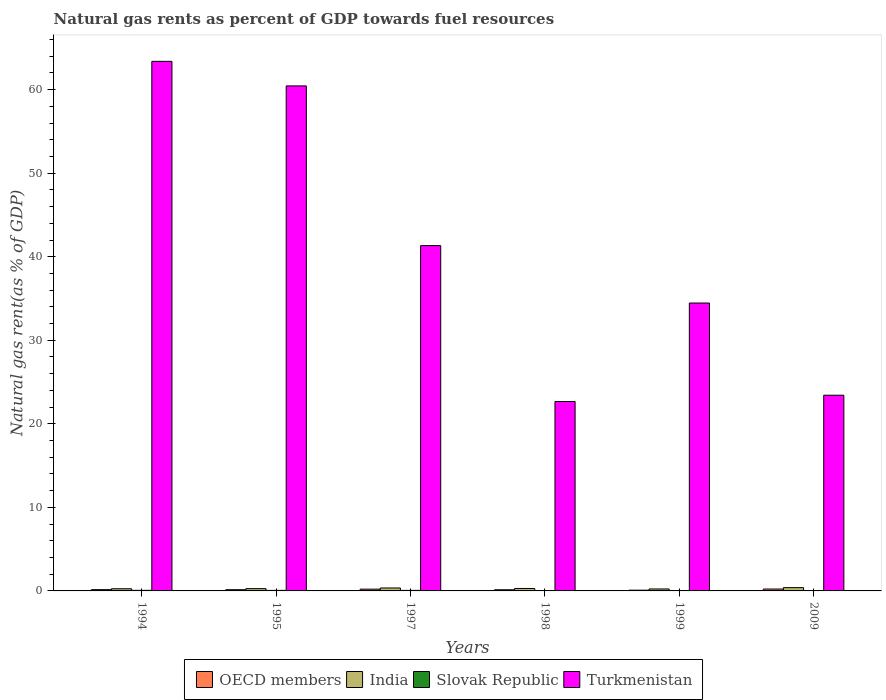How many groups of bars are there?
Provide a succinct answer. 6. Are the number of bars per tick equal to the number of legend labels?
Provide a succinct answer. Yes. How many bars are there on the 1st tick from the right?
Give a very brief answer. 4. What is the label of the 5th group of bars from the left?
Provide a succinct answer. 1999. In how many cases, is the number of bars for a given year not equal to the number of legend labels?
Your answer should be very brief. 0. What is the natural gas rent in India in 1994?
Your answer should be compact. 0.26. Across all years, what is the maximum natural gas rent in OECD members?
Your answer should be compact. 0.23. Across all years, what is the minimum natural gas rent in OECD members?
Make the answer very short. 0.09. What is the total natural gas rent in Turkmenistan in the graph?
Provide a short and direct response. 245.71. What is the difference between the natural gas rent in India in 1997 and that in 2009?
Your answer should be very brief. -0.04. What is the difference between the natural gas rent in India in 1997 and the natural gas rent in Slovak Republic in 1994?
Your response must be concise. 0.28. What is the average natural gas rent in Slovak Republic per year?
Offer a terse response. 0.05. In the year 2009, what is the difference between the natural gas rent in Turkmenistan and natural gas rent in OECD members?
Offer a very short reply. 23.2. What is the ratio of the natural gas rent in OECD members in 1997 to that in 1998?
Provide a succinct answer. 1.51. Is the natural gas rent in OECD members in 1997 less than that in 1998?
Provide a short and direct response. No. What is the difference between the highest and the second highest natural gas rent in India?
Make the answer very short. 0.04. What is the difference between the highest and the lowest natural gas rent in India?
Your answer should be very brief. 0.16. What does the 4th bar from the left in 1995 represents?
Provide a succinct answer. Turkmenistan. What does the 1st bar from the right in 2009 represents?
Provide a short and direct response. Turkmenistan. What is the difference between two consecutive major ticks on the Y-axis?
Give a very brief answer. 10. Does the graph contain any zero values?
Make the answer very short. No. Does the graph contain grids?
Ensure brevity in your answer.  No. Where does the legend appear in the graph?
Provide a succinct answer. Bottom center. How many legend labels are there?
Keep it short and to the point. 4. How are the legend labels stacked?
Make the answer very short. Horizontal. What is the title of the graph?
Your answer should be very brief. Natural gas rents as percent of GDP towards fuel resources. Does "Azerbaijan" appear as one of the legend labels in the graph?
Your response must be concise. No. What is the label or title of the Y-axis?
Your answer should be very brief. Natural gas rent(as % of GDP). What is the Natural gas rent(as % of GDP) of OECD members in 1994?
Your answer should be compact. 0.15. What is the Natural gas rent(as % of GDP) in India in 1994?
Your answer should be very brief. 0.26. What is the Natural gas rent(as % of GDP) in Slovak Republic in 1994?
Offer a very short reply. 0.07. What is the Natural gas rent(as % of GDP) in Turkmenistan in 1994?
Keep it short and to the point. 63.38. What is the Natural gas rent(as % of GDP) in OECD members in 1995?
Provide a succinct answer. 0.15. What is the Natural gas rent(as % of GDP) in India in 1995?
Make the answer very short. 0.27. What is the Natural gas rent(as % of GDP) in Slovak Republic in 1995?
Your answer should be very brief. 0.07. What is the Natural gas rent(as % of GDP) of Turkmenistan in 1995?
Make the answer very short. 60.45. What is the Natural gas rent(as % of GDP) in OECD members in 1997?
Ensure brevity in your answer.  0.21. What is the Natural gas rent(as % of GDP) in India in 1997?
Your response must be concise. 0.35. What is the Natural gas rent(as % of GDP) in Slovak Republic in 1997?
Your answer should be very brief. 0.06. What is the Natural gas rent(as % of GDP) of Turkmenistan in 1997?
Ensure brevity in your answer.  41.33. What is the Natural gas rent(as % of GDP) of OECD members in 1998?
Your answer should be compact. 0.14. What is the Natural gas rent(as % of GDP) in India in 1998?
Give a very brief answer. 0.29. What is the Natural gas rent(as % of GDP) in Slovak Republic in 1998?
Provide a succinct answer. 0.04. What is the Natural gas rent(as % of GDP) in Turkmenistan in 1998?
Provide a succinct answer. 22.67. What is the Natural gas rent(as % of GDP) of OECD members in 1999?
Keep it short and to the point. 0.09. What is the Natural gas rent(as % of GDP) in India in 1999?
Your answer should be compact. 0.23. What is the Natural gas rent(as % of GDP) in Slovak Republic in 1999?
Keep it short and to the point. 0.03. What is the Natural gas rent(as % of GDP) of Turkmenistan in 1999?
Ensure brevity in your answer.  34.46. What is the Natural gas rent(as % of GDP) in OECD members in 2009?
Your response must be concise. 0.23. What is the Natural gas rent(as % of GDP) of India in 2009?
Give a very brief answer. 0.39. What is the Natural gas rent(as % of GDP) in Slovak Republic in 2009?
Your answer should be compact. 0.02. What is the Natural gas rent(as % of GDP) of Turkmenistan in 2009?
Offer a very short reply. 23.42. Across all years, what is the maximum Natural gas rent(as % of GDP) of OECD members?
Offer a very short reply. 0.23. Across all years, what is the maximum Natural gas rent(as % of GDP) in India?
Your answer should be very brief. 0.39. Across all years, what is the maximum Natural gas rent(as % of GDP) of Slovak Republic?
Your answer should be very brief. 0.07. Across all years, what is the maximum Natural gas rent(as % of GDP) in Turkmenistan?
Offer a very short reply. 63.38. Across all years, what is the minimum Natural gas rent(as % of GDP) in OECD members?
Provide a succinct answer. 0.09. Across all years, what is the minimum Natural gas rent(as % of GDP) in India?
Your answer should be compact. 0.23. Across all years, what is the minimum Natural gas rent(as % of GDP) in Slovak Republic?
Offer a very short reply. 0.02. Across all years, what is the minimum Natural gas rent(as % of GDP) in Turkmenistan?
Provide a short and direct response. 22.67. What is the total Natural gas rent(as % of GDP) of OECD members in the graph?
Your response must be concise. 0.97. What is the total Natural gas rent(as % of GDP) in India in the graph?
Provide a short and direct response. 1.81. What is the total Natural gas rent(as % of GDP) in Slovak Republic in the graph?
Provide a succinct answer. 0.28. What is the total Natural gas rent(as % of GDP) in Turkmenistan in the graph?
Offer a terse response. 245.71. What is the difference between the Natural gas rent(as % of GDP) of OECD members in 1994 and that in 1995?
Offer a terse response. 0.01. What is the difference between the Natural gas rent(as % of GDP) in India in 1994 and that in 1995?
Give a very brief answer. -0.01. What is the difference between the Natural gas rent(as % of GDP) of Slovak Republic in 1994 and that in 1995?
Your answer should be compact. 0. What is the difference between the Natural gas rent(as % of GDP) of Turkmenistan in 1994 and that in 1995?
Provide a short and direct response. 2.94. What is the difference between the Natural gas rent(as % of GDP) in OECD members in 1994 and that in 1997?
Your response must be concise. -0.06. What is the difference between the Natural gas rent(as % of GDP) in India in 1994 and that in 1997?
Your response must be concise. -0.09. What is the difference between the Natural gas rent(as % of GDP) of Slovak Republic in 1994 and that in 1997?
Provide a succinct answer. 0. What is the difference between the Natural gas rent(as % of GDP) in Turkmenistan in 1994 and that in 1997?
Give a very brief answer. 22.05. What is the difference between the Natural gas rent(as % of GDP) in OECD members in 1994 and that in 1998?
Keep it short and to the point. 0.01. What is the difference between the Natural gas rent(as % of GDP) in India in 1994 and that in 1998?
Offer a very short reply. -0.03. What is the difference between the Natural gas rent(as % of GDP) of Slovak Republic in 1994 and that in 1998?
Make the answer very short. 0.03. What is the difference between the Natural gas rent(as % of GDP) in Turkmenistan in 1994 and that in 1998?
Keep it short and to the point. 40.71. What is the difference between the Natural gas rent(as % of GDP) of OECD members in 1994 and that in 1999?
Keep it short and to the point. 0.07. What is the difference between the Natural gas rent(as % of GDP) in India in 1994 and that in 1999?
Provide a short and direct response. 0.02. What is the difference between the Natural gas rent(as % of GDP) of Slovak Republic in 1994 and that in 1999?
Provide a short and direct response. 0.04. What is the difference between the Natural gas rent(as % of GDP) of Turkmenistan in 1994 and that in 1999?
Make the answer very short. 28.93. What is the difference between the Natural gas rent(as % of GDP) of OECD members in 1994 and that in 2009?
Provide a short and direct response. -0.07. What is the difference between the Natural gas rent(as % of GDP) in India in 1994 and that in 2009?
Provide a succinct answer. -0.14. What is the difference between the Natural gas rent(as % of GDP) in Slovak Republic in 1994 and that in 2009?
Provide a short and direct response. 0.05. What is the difference between the Natural gas rent(as % of GDP) of Turkmenistan in 1994 and that in 2009?
Give a very brief answer. 39.96. What is the difference between the Natural gas rent(as % of GDP) in OECD members in 1995 and that in 1997?
Ensure brevity in your answer.  -0.07. What is the difference between the Natural gas rent(as % of GDP) in India in 1995 and that in 1997?
Provide a succinct answer. -0.08. What is the difference between the Natural gas rent(as % of GDP) in Slovak Republic in 1995 and that in 1997?
Your answer should be very brief. 0. What is the difference between the Natural gas rent(as % of GDP) of Turkmenistan in 1995 and that in 1997?
Your response must be concise. 19.12. What is the difference between the Natural gas rent(as % of GDP) in OECD members in 1995 and that in 1998?
Your response must be concise. 0.01. What is the difference between the Natural gas rent(as % of GDP) in India in 1995 and that in 1998?
Make the answer very short. -0.02. What is the difference between the Natural gas rent(as % of GDP) in Slovak Republic in 1995 and that in 1998?
Make the answer very short. 0.02. What is the difference between the Natural gas rent(as % of GDP) of Turkmenistan in 1995 and that in 1998?
Your answer should be compact. 37.78. What is the difference between the Natural gas rent(as % of GDP) of OECD members in 1995 and that in 1999?
Your response must be concise. 0.06. What is the difference between the Natural gas rent(as % of GDP) of India in 1995 and that in 1999?
Your answer should be very brief. 0.04. What is the difference between the Natural gas rent(as % of GDP) in Slovak Republic in 1995 and that in 1999?
Keep it short and to the point. 0.04. What is the difference between the Natural gas rent(as % of GDP) of Turkmenistan in 1995 and that in 1999?
Your answer should be very brief. 25.99. What is the difference between the Natural gas rent(as % of GDP) of OECD members in 1995 and that in 2009?
Your answer should be very brief. -0.08. What is the difference between the Natural gas rent(as % of GDP) of India in 1995 and that in 2009?
Your answer should be compact. -0.12. What is the difference between the Natural gas rent(as % of GDP) of Slovak Republic in 1995 and that in 2009?
Provide a succinct answer. 0.05. What is the difference between the Natural gas rent(as % of GDP) of Turkmenistan in 1995 and that in 2009?
Ensure brevity in your answer.  37.02. What is the difference between the Natural gas rent(as % of GDP) of OECD members in 1997 and that in 1998?
Your answer should be compact. 0.07. What is the difference between the Natural gas rent(as % of GDP) of India in 1997 and that in 1998?
Provide a short and direct response. 0.06. What is the difference between the Natural gas rent(as % of GDP) in Slovak Republic in 1997 and that in 1998?
Your response must be concise. 0.02. What is the difference between the Natural gas rent(as % of GDP) in Turkmenistan in 1997 and that in 1998?
Provide a succinct answer. 18.66. What is the difference between the Natural gas rent(as % of GDP) of OECD members in 1997 and that in 1999?
Provide a succinct answer. 0.12. What is the difference between the Natural gas rent(as % of GDP) of India in 1997 and that in 1999?
Ensure brevity in your answer.  0.12. What is the difference between the Natural gas rent(as % of GDP) of Slovak Republic in 1997 and that in 1999?
Your response must be concise. 0.04. What is the difference between the Natural gas rent(as % of GDP) of Turkmenistan in 1997 and that in 1999?
Give a very brief answer. 6.87. What is the difference between the Natural gas rent(as % of GDP) in OECD members in 1997 and that in 2009?
Ensure brevity in your answer.  -0.01. What is the difference between the Natural gas rent(as % of GDP) of India in 1997 and that in 2009?
Your answer should be very brief. -0.04. What is the difference between the Natural gas rent(as % of GDP) of Slovak Republic in 1997 and that in 2009?
Your answer should be compact. 0.05. What is the difference between the Natural gas rent(as % of GDP) in Turkmenistan in 1997 and that in 2009?
Your answer should be compact. 17.9. What is the difference between the Natural gas rent(as % of GDP) of OECD members in 1998 and that in 1999?
Make the answer very short. 0.05. What is the difference between the Natural gas rent(as % of GDP) in India in 1998 and that in 1999?
Make the answer very short. 0.06. What is the difference between the Natural gas rent(as % of GDP) of Slovak Republic in 1998 and that in 1999?
Your response must be concise. 0.01. What is the difference between the Natural gas rent(as % of GDP) in Turkmenistan in 1998 and that in 1999?
Ensure brevity in your answer.  -11.79. What is the difference between the Natural gas rent(as % of GDP) of OECD members in 1998 and that in 2009?
Your response must be concise. -0.09. What is the difference between the Natural gas rent(as % of GDP) of India in 1998 and that in 2009?
Make the answer very short. -0.1. What is the difference between the Natural gas rent(as % of GDP) of Slovak Republic in 1998 and that in 2009?
Offer a terse response. 0.02. What is the difference between the Natural gas rent(as % of GDP) in Turkmenistan in 1998 and that in 2009?
Keep it short and to the point. -0.76. What is the difference between the Natural gas rent(as % of GDP) of OECD members in 1999 and that in 2009?
Provide a short and direct response. -0.14. What is the difference between the Natural gas rent(as % of GDP) in India in 1999 and that in 2009?
Your answer should be compact. -0.16. What is the difference between the Natural gas rent(as % of GDP) in Slovak Republic in 1999 and that in 2009?
Offer a terse response. 0.01. What is the difference between the Natural gas rent(as % of GDP) in Turkmenistan in 1999 and that in 2009?
Your response must be concise. 11.03. What is the difference between the Natural gas rent(as % of GDP) of OECD members in 1994 and the Natural gas rent(as % of GDP) of India in 1995?
Your response must be concise. -0.12. What is the difference between the Natural gas rent(as % of GDP) of OECD members in 1994 and the Natural gas rent(as % of GDP) of Slovak Republic in 1995?
Your answer should be very brief. 0.09. What is the difference between the Natural gas rent(as % of GDP) of OECD members in 1994 and the Natural gas rent(as % of GDP) of Turkmenistan in 1995?
Offer a terse response. -60.29. What is the difference between the Natural gas rent(as % of GDP) in India in 1994 and the Natural gas rent(as % of GDP) in Slovak Republic in 1995?
Give a very brief answer. 0.19. What is the difference between the Natural gas rent(as % of GDP) in India in 1994 and the Natural gas rent(as % of GDP) in Turkmenistan in 1995?
Offer a very short reply. -60.19. What is the difference between the Natural gas rent(as % of GDP) of Slovak Republic in 1994 and the Natural gas rent(as % of GDP) of Turkmenistan in 1995?
Make the answer very short. -60.38. What is the difference between the Natural gas rent(as % of GDP) in OECD members in 1994 and the Natural gas rent(as % of GDP) in India in 1997?
Keep it short and to the point. -0.2. What is the difference between the Natural gas rent(as % of GDP) of OECD members in 1994 and the Natural gas rent(as % of GDP) of Slovak Republic in 1997?
Your answer should be very brief. 0.09. What is the difference between the Natural gas rent(as % of GDP) of OECD members in 1994 and the Natural gas rent(as % of GDP) of Turkmenistan in 1997?
Keep it short and to the point. -41.18. What is the difference between the Natural gas rent(as % of GDP) in India in 1994 and the Natural gas rent(as % of GDP) in Slovak Republic in 1997?
Make the answer very short. 0.19. What is the difference between the Natural gas rent(as % of GDP) of India in 1994 and the Natural gas rent(as % of GDP) of Turkmenistan in 1997?
Your response must be concise. -41.07. What is the difference between the Natural gas rent(as % of GDP) in Slovak Republic in 1994 and the Natural gas rent(as % of GDP) in Turkmenistan in 1997?
Keep it short and to the point. -41.26. What is the difference between the Natural gas rent(as % of GDP) in OECD members in 1994 and the Natural gas rent(as % of GDP) in India in 1998?
Ensure brevity in your answer.  -0.14. What is the difference between the Natural gas rent(as % of GDP) of OECD members in 1994 and the Natural gas rent(as % of GDP) of Slovak Republic in 1998?
Ensure brevity in your answer.  0.11. What is the difference between the Natural gas rent(as % of GDP) of OECD members in 1994 and the Natural gas rent(as % of GDP) of Turkmenistan in 1998?
Ensure brevity in your answer.  -22.52. What is the difference between the Natural gas rent(as % of GDP) of India in 1994 and the Natural gas rent(as % of GDP) of Slovak Republic in 1998?
Your answer should be compact. 0.22. What is the difference between the Natural gas rent(as % of GDP) in India in 1994 and the Natural gas rent(as % of GDP) in Turkmenistan in 1998?
Your response must be concise. -22.41. What is the difference between the Natural gas rent(as % of GDP) in Slovak Republic in 1994 and the Natural gas rent(as % of GDP) in Turkmenistan in 1998?
Provide a succinct answer. -22.6. What is the difference between the Natural gas rent(as % of GDP) of OECD members in 1994 and the Natural gas rent(as % of GDP) of India in 1999?
Your response must be concise. -0.08. What is the difference between the Natural gas rent(as % of GDP) in OECD members in 1994 and the Natural gas rent(as % of GDP) in Slovak Republic in 1999?
Provide a succinct answer. 0.13. What is the difference between the Natural gas rent(as % of GDP) of OECD members in 1994 and the Natural gas rent(as % of GDP) of Turkmenistan in 1999?
Your answer should be compact. -34.3. What is the difference between the Natural gas rent(as % of GDP) of India in 1994 and the Natural gas rent(as % of GDP) of Slovak Republic in 1999?
Provide a succinct answer. 0.23. What is the difference between the Natural gas rent(as % of GDP) of India in 1994 and the Natural gas rent(as % of GDP) of Turkmenistan in 1999?
Provide a short and direct response. -34.2. What is the difference between the Natural gas rent(as % of GDP) in Slovak Republic in 1994 and the Natural gas rent(as % of GDP) in Turkmenistan in 1999?
Keep it short and to the point. -34.39. What is the difference between the Natural gas rent(as % of GDP) in OECD members in 1994 and the Natural gas rent(as % of GDP) in India in 2009?
Offer a very short reply. -0.24. What is the difference between the Natural gas rent(as % of GDP) of OECD members in 1994 and the Natural gas rent(as % of GDP) of Slovak Republic in 2009?
Provide a short and direct response. 0.14. What is the difference between the Natural gas rent(as % of GDP) of OECD members in 1994 and the Natural gas rent(as % of GDP) of Turkmenistan in 2009?
Your answer should be very brief. -23.27. What is the difference between the Natural gas rent(as % of GDP) of India in 1994 and the Natural gas rent(as % of GDP) of Slovak Republic in 2009?
Offer a terse response. 0.24. What is the difference between the Natural gas rent(as % of GDP) of India in 1994 and the Natural gas rent(as % of GDP) of Turkmenistan in 2009?
Your answer should be very brief. -23.17. What is the difference between the Natural gas rent(as % of GDP) of Slovak Republic in 1994 and the Natural gas rent(as % of GDP) of Turkmenistan in 2009?
Your response must be concise. -23.36. What is the difference between the Natural gas rent(as % of GDP) in OECD members in 1995 and the Natural gas rent(as % of GDP) in India in 1997?
Offer a very short reply. -0.21. What is the difference between the Natural gas rent(as % of GDP) in OECD members in 1995 and the Natural gas rent(as % of GDP) in Slovak Republic in 1997?
Keep it short and to the point. 0.08. What is the difference between the Natural gas rent(as % of GDP) in OECD members in 1995 and the Natural gas rent(as % of GDP) in Turkmenistan in 1997?
Your answer should be very brief. -41.18. What is the difference between the Natural gas rent(as % of GDP) of India in 1995 and the Natural gas rent(as % of GDP) of Slovak Republic in 1997?
Ensure brevity in your answer.  0.21. What is the difference between the Natural gas rent(as % of GDP) in India in 1995 and the Natural gas rent(as % of GDP) in Turkmenistan in 1997?
Your response must be concise. -41.06. What is the difference between the Natural gas rent(as % of GDP) in Slovak Republic in 1995 and the Natural gas rent(as % of GDP) in Turkmenistan in 1997?
Ensure brevity in your answer.  -41.26. What is the difference between the Natural gas rent(as % of GDP) in OECD members in 1995 and the Natural gas rent(as % of GDP) in India in 1998?
Offer a very short reply. -0.15. What is the difference between the Natural gas rent(as % of GDP) of OECD members in 1995 and the Natural gas rent(as % of GDP) of Slovak Republic in 1998?
Offer a terse response. 0.11. What is the difference between the Natural gas rent(as % of GDP) of OECD members in 1995 and the Natural gas rent(as % of GDP) of Turkmenistan in 1998?
Offer a very short reply. -22.52. What is the difference between the Natural gas rent(as % of GDP) of India in 1995 and the Natural gas rent(as % of GDP) of Slovak Republic in 1998?
Offer a terse response. 0.23. What is the difference between the Natural gas rent(as % of GDP) of India in 1995 and the Natural gas rent(as % of GDP) of Turkmenistan in 1998?
Offer a very short reply. -22.4. What is the difference between the Natural gas rent(as % of GDP) in Slovak Republic in 1995 and the Natural gas rent(as % of GDP) in Turkmenistan in 1998?
Make the answer very short. -22.6. What is the difference between the Natural gas rent(as % of GDP) in OECD members in 1995 and the Natural gas rent(as % of GDP) in India in 1999?
Make the answer very short. -0.09. What is the difference between the Natural gas rent(as % of GDP) of OECD members in 1995 and the Natural gas rent(as % of GDP) of Slovak Republic in 1999?
Make the answer very short. 0.12. What is the difference between the Natural gas rent(as % of GDP) of OECD members in 1995 and the Natural gas rent(as % of GDP) of Turkmenistan in 1999?
Your answer should be very brief. -34.31. What is the difference between the Natural gas rent(as % of GDP) of India in 1995 and the Natural gas rent(as % of GDP) of Slovak Republic in 1999?
Your answer should be compact. 0.25. What is the difference between the Natural gas rent(as % of GDP) in India in 1995 and the Natural gas rent(as % of GDP) in Turkmenistan in 1999?
Your response must be concise. -34.18. What is the difference between the Natural gas rent(as % of GDP) in Slovak Republic in 1995 and the Natural gas rent(as % of GDP) in Turkmenistan in 1999?
Offer a terse response. -34.39. What is the difference between the Natural gas rent(as % of GDP) in OECD members in 1995 and the Natural gas rent(as % of GDP) in India in 2009?
Your answer should be compact. -0.25. What is the difference between the Natural gas rent(as % of GDP) of OECD members in 1995 and the Natural gas rent(as % of GDP) of Slovak Republic in 2009?
Offer a terse response. 0.13. What is the difference between the Natural gas rent(as % of GDP) of OECD members in 1995 and the Natural gas rent(as % of GDP) of Turkmenistan in 2009?
Offer a terse response. -23.28. What is the difference between the Natural gas rent(as % of GDP) in India in 1995 and the Natural gas rent(as % of GDP) in Slovak Republic in 2009?
Provide a succinct answer. 0.26. What is the difference between the Natural gas rent(as % of GDP) in India in 1995 and the Natural gas rent(as % of GDP) in Turkmenistan in 2009?
Make the answer very short. -23.15. What is the difference between the Natural gas rent(as % of GDP) in Slovak Republic in 1995 and the Natural gas rent(as % of GDP) in Turkmenistan in 2009?
Provide a short and direct response. -23.36. What is the difference between the Natural gas rent(as % of GDP) in OECD members in 1997 and the Natural gas rent(as % of GDP) in India in 1998?
Your answer should be compact. -0.08. What is the difference between the Natural gas rent(as % of GDP) in OECD members in 1997 and the Natural gas rent(as % of GDP) in Slovak Republic in 1998?
Ensure brevity in your answer.  0.17. What is the difference between the Natural gas rent(as % of GDP) in OECD members in 1997 and the Natural gas rent(as % of GDP) in Turkmenistan in 1998?
Provide a short and direct response. -22.46. What is the difference between the Natural gas rent(as % of GDP) of India in 1997 and the Natural gas rent(as % of GDP) of Slovak Republic in 1998?
Offer a very short reply. 0.31. What is the difference between the Natural gas rent(as % of GDP) in India in 1997 and the Natural gas rent(as % of GDP) in Turkmenistan in 1998?
Your answer should be very brief. -22.32. What is the difference between the Natural gas rent(as % of GDP) in Slovak Republic in 1997 and the Natural gas rent(as % of GDP) in Turkmenistan in 1998?
Ensure brevity in your answer.  -22.61. What is the difference between the Natural gas rent(as % of GDP) of OECD members in 1997 and the Natural gas rent(as % of GDP) of India in 1999?
Give a very brief answer. -0.02. What is the difference between the Natural gas rent(as % of GDP) of OECD members in 1997 and the Natural gas rent(as % of GDP) of Slovak Republic in 1999?
Make the answer very short. 0.18. What is the difference between the Natural gas rent(as % of GDP) in OECD members in 1997 and the Natural gas rent(as % of GDP) in Turkmenistan in 1999?
Offer a terse response. -34.25. What is the difference between the Natural gas rent(as % of GDP) of India in 1997 and the Natural gas rent(as % of GDP) of Slovak Republic in 1999?
Keep it short and to the point. 0.32. What is the difference between the Natural gas rent(as % of GDP) in India in 1997 and the Natural gas rent(as % of GDP) in Turkmenistan in 1999?
Your answer should be compact. -34.11. What is the difference between the Natural gas rent(as % of GDP) in Slovak Republic in 1997 and the Natural gas rent(as % of GDP) in Turkmenistan in 1999?
Provide a succinct answer. -34.39. What is the difference between the Natural gas rent(as % of GDP) of OECD members in 1997 and the Natural gas rent(as % of GDP) of India in 2009?
Your answer should be very brief. -0.18. What is the difference between the Natural gas rent(as % of GDP) of OECD members in 1997 and the Natural gas rent(as % of GDP) of Slovak Republic in 2009?
Give a very brief answer. 0.2. What is the difference between the Natural gas rent(as % of GDP) in OECD members in 1997 and the Natural gas rent(as % of GDP) in Turkmenistan in 2009?
Your answer should be compact. -23.21. What is the difference between the Natural gas rent(as % of GDP) of India in 1997 and the Natural gas rent(as % of GDP) of Slovak Republic in 2009?
Provide a short and direct response. 0.34. What is the difference between the Natural gas rent(as % of GDP) of India in 1997 and the Natural gas rent(as % of GDP) of Turkmenistan in 2009?
Ensure brevity in your answer.  -23.07. What is the difference between the Natural gas rent(as % of GDP) in Slovak Republic in 1997 and the Natural gas rent(as % of GDP) in Turkmenistan in 2009?
Provide a succinct answer. -23.36. What is the difference between the Natural gas rent(as % of GDP) in OECD members in 1998 and the Natural gas rent(as % of GDP) in India in 1999?
Your response must be concise. -0.09. What is the difference between the Natural gas rent(as % of GDP) of OECD members in 1998 and the Natural gas rent(as % of GDP) of Slovak Republic in 1999?
Offer a very short reply. 0.11. What is the difference between the Natural gas rent(as % of GDP) of OECD members in 1998 and the Natural gas rent(as % of GDP) of Turkmenistan in 1999?
Your response must be concise. -34.32. What is the difference between the Natural gas rent(as % of GDP) in India in 1998 and the Natural gas rent(as % of GDP) in Slovak Republic in 1999?
Ensure brevity in your answer.  0.27. What is the difference between the Natural gas rent(as % of GDP) of India in 1998 and the Natural gas rent(as % of GDP) of Turkmenistan in 1999?
Give a very brief answer. -34.16. What is the difference between the Natural gas rent(as % of GDP) in Slovak Republic in 1998 and the Natural gas rent(as % of GDP) in Turkmenistan in 1999?
Give a very brief answer. -34.42. What is the difference between the Natural gas rent(as % of GDP) in OECD members in 1998 and the Natural gas rent(as % of GDP) in India in 2009?
Offer a very short reply. -0.25. What is the difference between the Natural gas rent(as % of GDP) of OECD members in 1998 and the Natural gas rent(as % of GDP) of Slovak Republic in 2009?
Keep it short and to the point. 0.12. What is the difference between the Natural gas rent(as % of GDP) in OECD members in 1998 and the Natural gas rent(as % of GDP) in Turkmenistan in 2009?
Your answer should be very brief. -23.28. What is the difference between the Natural gas rent(as % of GDP) in India in 1998 and the Natural gas rent(as % of GDP) in Slovak Republic in 2009?
Your response must be concise. 0.28. What is the difference between the Natural gas rent(as % of GDP) of India in 1998 and the Natural gas rent(as % of GDP) of Turkmenistan in 2009?
Offer a very short reply. -23.13. What is the difference between the Natural gas rent(as % of GDP) of Slovak Republic in 1998 and the Natural gas rent(as % of GDP) of Turkmenistan in 2009?
Offer a very short reply. -23.38. What is the difference between the Natural gas rent(as % of GDP) in OECD members in 1999 and the Natural gas rent(as % of GDP) in India in 2009?
Provide a succinct answer. -0.31. What is the difference between the Natural gas rent(as % of GDP) of OECD members in 1999 and the Natural gas rent(as % of GDP) of Slovak Republic in 2009?
Offer a terse response. 0.07. What is the difference between the Natural gas rent(as % of GDP) of OECD members in 1999 and the Natural gas rent(as % of GDP) of Turkmenistan in 2009?
Give a very brief answer. -23.34. What is the difference between the Natural gas rent(as % of GDP) in India in 1999 and the Natural gas rent(as % of GDP) in Slovak Republic in 2009?
Your answer should be very brief. 0.22. What is the difference between the Natural gas rent(as % of GDP) of India in 1999 and the Natural gas rent(as % of GDP) of Turkmenistan in 2009?
Provide a succinct answer. -23.19. What is the difference between the Natural gas rent(as % of GDP) in Slovak Republic in 1999 and the Natural gas rent(as % of GDP) in Turkmenistan in 2009?
Make the answer very short. -23.4. What is the average Natural gas rent(as % of GDP) in OECD members per year?
Ensure brevity in your answer.  0.16. What is the average Natural gas rent(as % of GDP) in India per year?
Provide a short and direct response. 0.3. What is the average Natural gas rent(as % of GDP) of Slovak Republic per year?
Offer a very short reply. 0.05. What is the average Natural gas rent(as % of GDP) in Turkmenistan per year?
Give a very brief answer. 40.95. In the year 1994, what is the difference between the Natural gas rent(as % of GDP) of OECD members and Natural gas rent(as % of GDP) of India?
Give a very brief answer. -0.1. In the year 1994, what is the difference between the Natural gas rent(as % of GDP) in OECD members and Natural gas rent(as % of GDP) in Slovak Republic?
Your answer should be very brief. 0.09. In the year 1994, what is the difference between the Natural gas rent(as % of GDP) in OECD members and Natural gas rent(as % of GDP) in Turkmenistan?
Offer a very short reply. -63.23. In the year 1994, what is the difference between the Natural gas rent(as % of GDP) in India and Natural gas rent(as % of GDP) in Slovak Republic?
Provide a succinct answer. 0.19. In the year 1994, what is the difference between the Natural gas rent(as % of GDP) in India and Natural gas rent(as % of GDP) in Turkmenistan?
Your answer should be compact. -63.13. In the year 1994, what is the difference between the Natural gas rent(as % of GDP) of Slovak Republic and Natural gas rent(as % of GDP) of Turkmenistan?
Ensure brevity in your answer.  -63.32. In the year 1995, what is the difference between the Natural gas rent(as % of GDP) of OECD members and Natural gas rent(as % of GDP) of India?
Make the answer very short. -0.13. In the year 1995, what is the difference between the Natural gas rent(as % of GDP) of OECD members and Natural gas rent(as % of GDP) of Slovak Republic?
Ensure brevity in your answer.  0.08. In the year 1995, what is the difference between the Natural gas rent(as % of GDP) of OECD members and Natural gas rent(as % of GDP) of Turkmenistan?
Your answer should be compact. -60.3. In the year 1995, what is the difference between the Natural gas rent(as % of GDP) of India and Natural gas rent(as % of GDP) of Slovak Republic?
Offer a very short reply. 0.21. In the year 1995, what is the difference between the Natural gas rent(as % of GDP) in India and Natural gas rent(as % of GDP) in Turkmenistan?
Your answer should be very brief. -60.17. In the year 1995, what is the difference between the Natural gas rent(as % of GDP) of Slovak Republic and Natural gas rent(as % of GDP) of Turkmenistan?
Make the answer very short. -60.38. In the year 1997, what is the difference between the Natural gas rent(as % of GDP) in OECD members and Natural gas rent(as % of GDP) in India?
Ensure brevity in your answer.  -0.14. In the year 1997, what is the difference between the Natural gas rent(as % of GDP) of OECD members and Natural gas rent(as % of GDP) of Slovak Republic?
Ensure brevity in your answer.  0.15. In the year 1997, what is the difference between the Natural gas rent(as % of GDP) of OECD members and Natural gas rent(as % of GDP) of Turkmenistan?
Ensure brevity in your answer.  -41.12. In the year 1997, what is the difference between the Natural gas rent(as % of GDP) of India and Natural gas rent(as % of GDP) of Slovak Republic?
Keep it short and to the point. 0.29. In the year 1997, what is the difference between the Natural gas rent(as % of GDP) in India and Natural gas rent(as % of GDP) in Turkmenistan?
Provide a succinct answer. -40.98. In the year 1997, what is the difference between the Natural gas rent(as % of GDP) in Slovak Republic and Natural gas rent(as % of GDP) in Turkmenistan?
Provide a succinct answer. -41.27. In the year 1998, what is the difference between the Natural gas rent(as % of GDP) of OECD members and Natural gas rent(as % of GDP) of India?
Offer a very short reply. -0.15. In the year 1998, what is the difference between the Natural gas rent(as % of GDP) of OECD members and Natural gas rent(as % of GDP) of Slovak Republic?
Offer a terse response. 0.1. In the year 1998, what is the difference between the Natural gas rent(as % of GDP) in OECD members and Natural gas rent(as % of GDP) in Turkmenistan?
Your answer should be very brief. -22.53. In the year 1998, what is the difference between the Natural gas rent(as % of GDP) in India and Natural gas rent(as % of GDP) in Slovak Republic?
Provide a succinct answer. 0.25. In the year 1998, what is the difference between the Natural gas rent(as % of GDP) in India and Natural gas rent(as % of GDP) in Turkmenistan?
Give a very brief answer. -22.38. In the year 1998, what is the difference between the Natural gas rent(as % of GDP) in Slovak Republic and Natural gas rent(as % of GDP) in Turkmenistan?
Give a very brief answer. -22.63. In the year 1999, what is the difference between the Natural gas rent(as % of GDP) in OECD members and Natural gas rent(as % of GDP) in India?
Your answer should be compact. -0.15. In the year 1999, what is the difference between the Natural gas rent(as % of GDP) in OECD members and Natural gas rent(as % of GDP) in Slovak Republic?
Your answer should be compact. 0.06. In the year 1999, what is the difference between the Natural gas rent(as % of GDP) of OECD members and Natural gas rent(as % of GDP) of Turkmenistan?
Provide a short and direct response. -34.37. In the year 1999, what is the difference between the Natural gas rent(as % of GDP) in India and Natural gas rent(as % of GDP) in Slovak Republic?
Provide a succinct answer. 0.21. In the year 1999, what is the difference between the Natural gas rent(as % of GDP) in India and Natural gas rent(as % of GDP) in Turkmenistan?
Offer a terse response. -34.22. In the year 1999, what is the difference between the Natural gas rent(as % of GDP) in Slovak Republic and Natural gas rent(as % of GDP) in Turkmenistan?
Your answer should be compact. -34.43. In the year 2009, what is the difference between the Natural gas rent(as % of GDP) in OECD members and Natural gas rent(as % of GDP) in India?
Offer a very short reply. -0.17. In the year 2009, what is the difference between the Natural gas rent(as % of GDP) of OECD members and Natural gas rent(as % of GDP) of Slovak Republic?
Offer a terse response. 0.21. In the year 2009, what is the difference between the Natural gas rent(as % of GDP) in OECD members and Natural gas rent(as % of GDP) in Turkmenistan?
Keep it short and to the point. -23.2. In the year 2009, what is the difference between the Natural gas rent(as % of GDP) in India and Natural gas rent(as % of GDP) in Slovak Republic?
Your answer should be compact. 0.38. In the year 2009, what is the difference between the Natural gas rent(as % of GDP) of India and Natural gas rent(as % of GDP) of Turkmenistan?
Make the answer very short. -23.03. In the year 2009, what is the difference between the Natural gas rent(as % of GDP) of Slovak Republic and Natural gas rent(as % of GDP) of Turkmenistan?
Give a very brief answer. -23.41. What is the ratio of the Natural gas rent(as % of GDP) in OECD members in 1994 to that in 1995?
Your answer should be compact. 1.05. What is the ratio of the Natural gas rent(as % of GDP) in India in 1994 to that in 1995?
Give a very brief answer. 0.95. What is the ratio of the Natural gas rent(as % of GDP) in Slovak Republic in 1994 to that in 1995?
Provide a short and direct response. 1.06. What is the ratio of the Natural gas rent(as % of GDP) in Turkmenistan in 1994 to that in 1995?
Make the answer very short. 1.05. What is the ratio of the Natural gas rent(as % of GDP) of OECD members in 1994 to that in 1997?
Offer a terse response. 0.73. What is the ratio of the Natural gas rent(as % of GDP) of India in 1994 to that in 1997?
Provide a succinct answer. 0.74. What is the ratio of the Natural gas rent(as % of GDP) in Slovak Republic in 1994 to that in 1997?
Give a very brief answer. 1.07. What is the ratio of the Natural gas rent(as % of GDP) in Turkmenistan in 1994 to that in 1997?
Give a very brief answer. 1.53. What is the ratio of the Natural gas rent(as % of GDP) of OECD members in 1994 to that in 1998?
Give a very brief answer. 1.1. What is the ratio of the Natural gas rent(as % of GDP) of India in 1994 to that in 1998?
Your answer should be compact. 0.88. What is the ratio of the Natural gas rent(as % of GDP) of Slovak Republic in 1994 to that in 1998?
Offer a terse response. 1.69. What is the ratio of the Natural gas rent(as % of GDP) of Turkmenistan in 1994 to that in 1998?
Offer a very short reply. 2.8. What is the ratio of the Natural gas rent(as % of GDP) of OECD members in 1994 to that in 1999?
Provide a succinct answer. 1.74. What is the ratio of the Natural gas rent(as % of GDP) of India in 1994 to that in 1999?
Your answer should be compact. 1.1. What is the ratio of the Natural gas rent(as % of GDP) of Slovak Republic in 1994 to that in 1999?
Keep it short and to the point. 2.53. What is the ratio of the Natural gas rent(as % of GDP) of Turkmenistan in 1994 to that in 1999?
Keep it short and to the point. 1.84. What is the ratio of the Natural gas rent(as % of GDP) in OECD members in 1994 to that in 2009?
Provide a succinct answer. 0.68. What is the ratio of the Natural gas rent(as % of GDP) in India in 1994 to that in 2009?
Make the answer very short. 0.66. What is the ratio of the Natural gas rent(as % of GDP) of Slovak Republic in 1994 to that in 2009?
Your answer should be compact. 4.32. What is the ratio of the Natural gas rent(as % of GDP) of Turkmenistan in 1994 to that in 2009?
Provide a short and direct response. 2.71. What is the ratio of the Natural gas rent(as % of GDP) of OECD members in 1995 to that in 1997?
Offer a very short reply. 0.69. What is the ratio of the Natural gas rent(as % of GDP) in India in 1995 to that in 1997?
Provide a short and direct response. 0.78. What is the ratio of the Natural gas rent(as % of GDP) of Slovak Republic in 1995 to that in 1997?
Provide a succinct answer. 1.01. What is the ratio of the Natural gas rent(as % of GDP) in Turkmenistan in 1995 to that in 1997?
Provide a succinct answer. 1.46. What is the ratio of the Natural gas rent(as % of GDP) of OECD members in 1995 to that in 1998?
Provide a short and direct response. 1.05. What is the ratio of the Natural gas rent(as % of GDP) in India in 1995 to that in 1998?
Give a very brief answer. 0.93. What is the ratio of the Natural gas rent(as % of GDP) in Slovak Republic in 1995 to that in 1998?
Your response must be concise. 1.6. What is the ratio of the Natural gas rent(as % of GDP) in Turkmenistan in 1995 to that in 1998?
Provide a succinct answer. 2.67. What is the ratio of the Natural gas rent(as % of GDP) in OECD members in 1995 to that in 1999?
Your answer should be compact. 1.65. What is the ratio of the Natural gas rent(as % of GDP) in India in 1995 to that in 1999?
Your answer should be compact. 1.17. What is the ratio of the Natural gas rent(as % of GDP) of Slovak Republic in 1995 to that in 1999?
Your response must be concise. 2.39. What is the ratio of the Natural gas rent(as % of GDP) of Turkmenistan in 1995 to that in 1999?
Keep it short and to the point. 1.75. What is the ratio of the Natural gas rent(as % of GDP) of OECD members in 1995 to that in 2009?
Keep it short and to the point. 0.65. What is the ratio of the Natural gas rent(as % of GDP) of India in 1995 to that in 2009?
Give a very brief answer. 0.69. What is the ratio of the Natural gas rent(as % of GDP) in Slovak Republic in 1995 to that in 2009?
Make the answer very short. 4.09. What is the ratio of the Natural gas rent(as % of GDP) in Turkmenistan in 1995 to that in 2009?
Your answer should be compact. 2.58. What is the ratio of the Natural gas rent(as % of GDP) in OECD members in 1997 to that in 1998?
Give a very brief answer. 1.51. What is the ratio of the Natural gas rent(as % of GDP) of India in 1997 to that in 1998?
Provide a short and direct response. 1.2. What is the ratio of the Natural gas rent(as % of GDP) in Slovak Republic in 1997 to that in 1998?
Your answer should be compact. 1.58. What is the ratio of the Natural gas rent(as % of GDP) in Turkmenistan in 1997 to that in 1998?
Offer a terse response. 1.82. What is the ratio of the Natural gas rent(as % of GDP) of OECD members in 1997 to that in 1999?
Provide a succinct answer. 2.38. What is the ratio of the Natural gas rent(as % of GDP) in India in 1997 to that in 1999?
Your response must be concise. 1.5. What is the ratio of the Natural gas rent(as % of GDP) of Slovak Republic in 1997 to that in 1999?
Your response must be concise. 2.36. What is the ratio of the Natural gas rent(as % of GDP) in Turkmenistan in 1997 to that in 1999?
Offer a very short reply. 1.2. What is the ratio of the Natural gas rent(as % of GDP) of OECD members in 1997 to that in 2009?
Offer a very short reply. 0.94. What is the ratio of the Natural gas rent(as % of GDP) of India in 1997 to that in 2009?
Your answer should be very brief. 0.89. What is the ratio of the Natural gas rent(as % of GDP) in Slovak Republic in 1997 to that in 2009?
Provide a short and direct response. 4.04. What is the ratio of the Natural gas rent(as % of GDP) of Turkmenistan in 1997 to that in 2009?
Provide a short and direct response. 1.76. What is the ratio of the Natural gas rent(as % of GDP) of OECD members in 1998 to that in 1999?
Your answer should be compact. 1.57. What is the ratio of the Natural gas rent(as % of GDP) in India in 1998 to that in 1999?
Keep it short and to the point. 1.25. What is the ratio of the Natural gas rent(as % of GDP) of Slovak Republic in 1998 to that in 1999?
Your answer should be compact. 1.49. What is the ratio of the Natural gas rent(as % of GDP) in Turkmenistan in 1998 to that in 1999?
Keep it short and to the point. 0.66. What is the ratio of the Natural gas rent(as % of GDP) of OECD members in 1998 to that in 2009?
Make the answer very short. 0.62. What is the ratio of the Natural gas rent(as % of GDP) of India in 1998 to that in 2009?
Ensure brevity in your answer.  0.74. What is the ratio of the Natural gas rent(as % of GDP) in Slovak Republic in 1998 to that in 2009?
Keep it short and to the point. 2.56. What is the ratio of the Natural gas rent(as % of GDP) of Turkmenistan in 1998 to that in 2009?
Give a very brief answer. 0.97. What is the ratio of the Natural gas rent(as % of GDP) of OECD members in 1999 to that in 2009?
Offer a terse response. 0.39. What is the ratio of the Natural gas rent(as % of GDP) in India in 1999 to that in 2009?
Your answer should be compact. 0.59. What is the ratio of the Natural gas rent(as % of GDP) of Slovak Republic in 1999 to that in 2009?
Offer a terse response. 1.71. What is the ratio of the Natural gas rent(as % of GDP) of Turkmenistan in 1999 to that in 2009?
Your answer should be very brief. 1.47. What is the difference between the highest and the second highest Natural gas rent(as % of GDP) in OECD members?
Ensure brevity in your answer.  0.01. What is the difference between the highest and the second highest Natural gas rent(as % of GDP) in India?
Your response must be concise. 0.04. What is the difference between the highest and the second highest Natural gas rent(as % of GDP) in Slovak Republic?
Your answer should be compact. 0. What is the difference between the highest and the second highest Natural gas rent(as % of GDP) of Turkmenistan?
Provide a short and direct response. 2.94. What is the difference between the highest and the lowest Natural gas rent(as % of GDP) in OECD members?
Make the answer very short. 0.14. What is the difference between the highest and the lowest Natural gas rent(as % of GDP) in India?
Offer a terse response. 0.16. What is the difference between the highest and the lowest Natural gas rent(as % of GDP) in Slovak Republic?
Your answer should be compact. 0.05. What is the difference between the highest and the lowest Natural gas rent(as % of GDP) of Turkmenistan?
Provide a short and direct response. 40.71. 